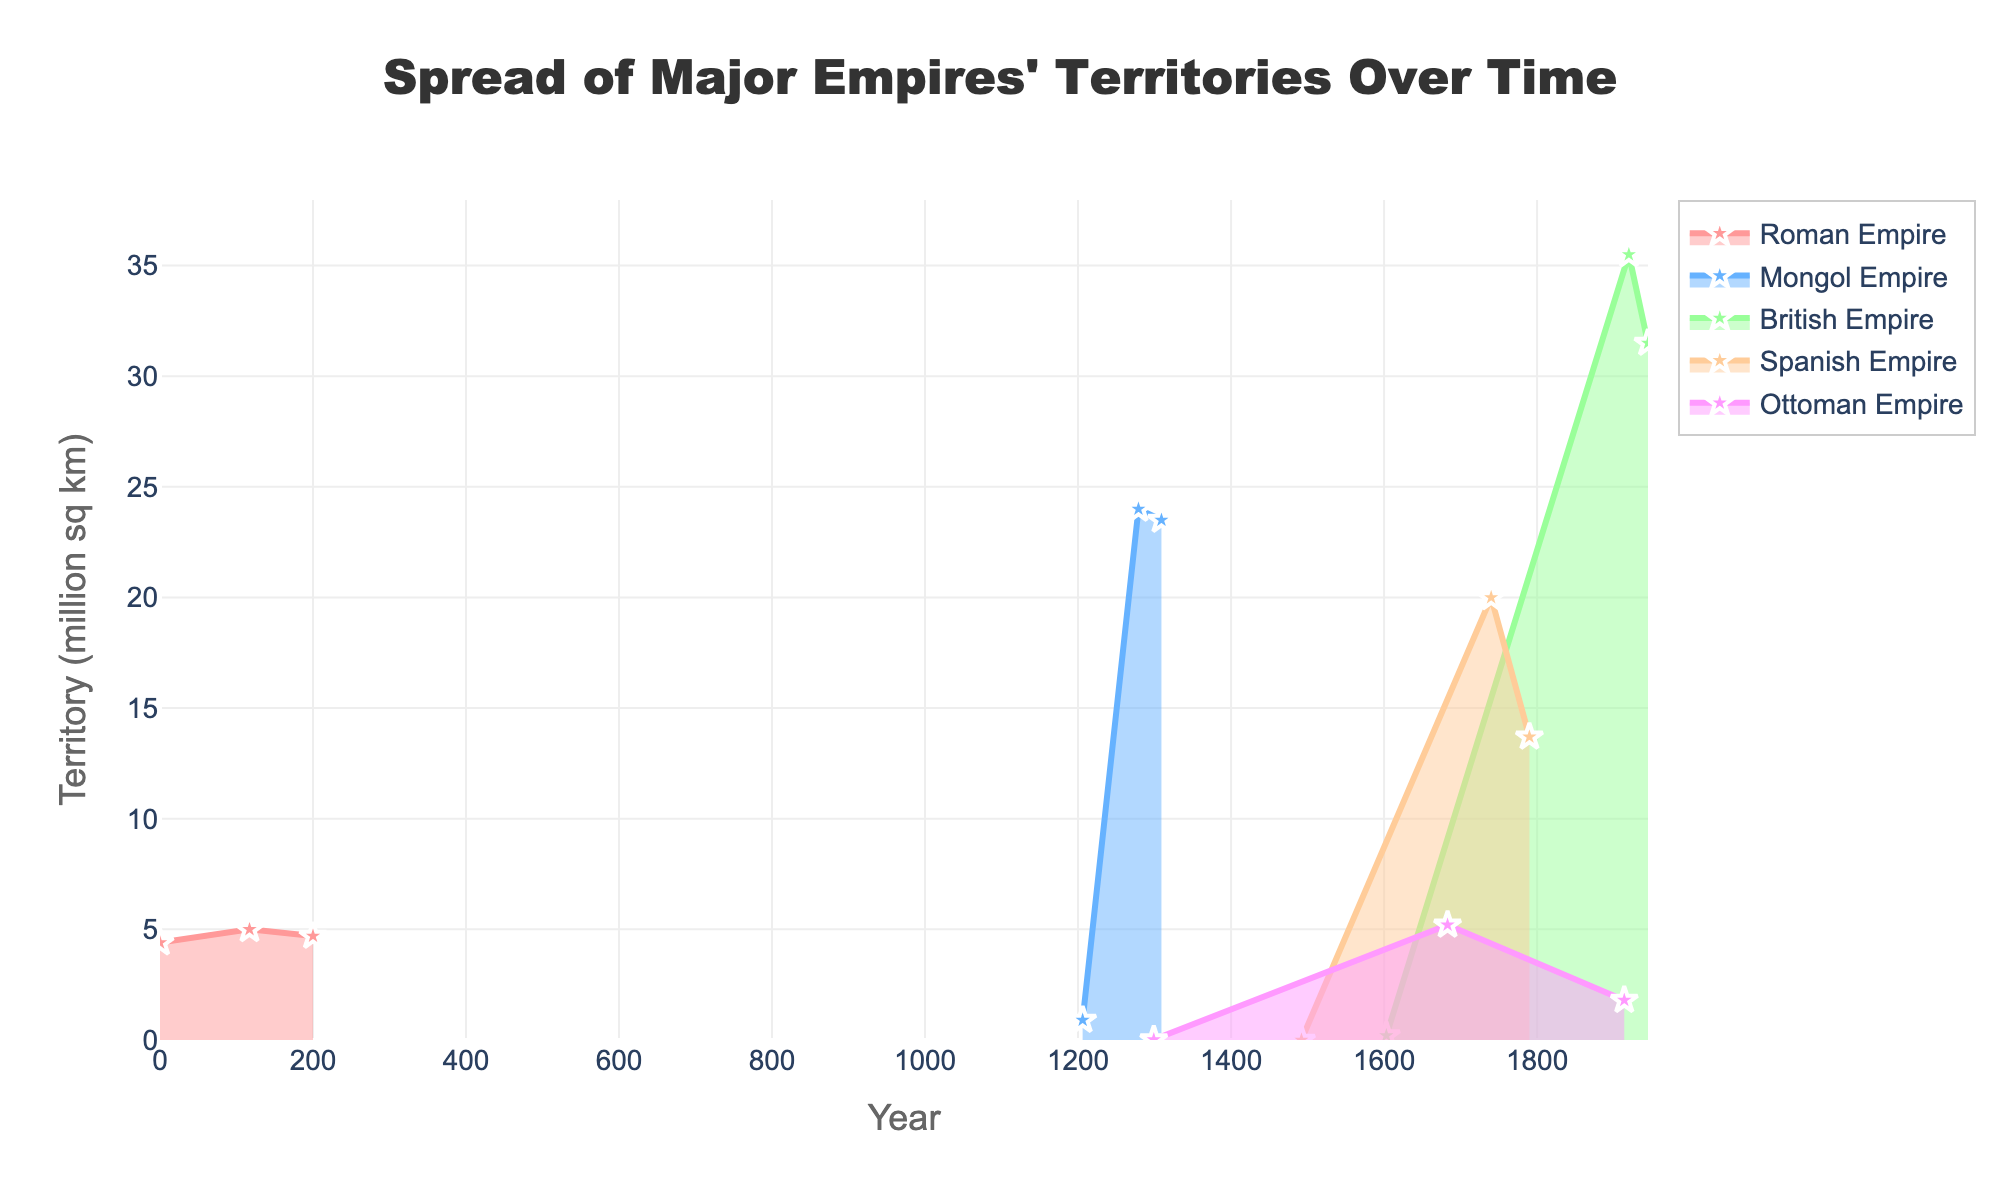What is the title of this figure? The title is written at the top center of the chart, in a large font size. It reads "Spread of Major Empires' Territories Over Time".
Answer: Spread of Major Empires' Territories Over Time Which empire had the largest territory at its peak according to the chart? The British Empire had the largest territory, reaching its peak at about 35.5 million sq km around the year 1920.
Answer: British Empire How did the territory of the Roman Empire change between 0 and 200 AD? From the plot, we see that the Roman Empire's territory grew from 4.4 million sq km in year 0 to 5 million sq km by year 117 AD, and then slightly decreased to 4.7 million sq km by the year 200 AD. This shows an initial increase followed by a slight decrease.
Answer: Increased, then decreased Which empire expanded the fastest during the covered time periods? The Mongol Empire shows the most rapid expansion, growing from 0.9 million sq km in 1206 to 24 million sq km by 1279.
Answer: Mongol Empire Compare the size of the Ottoman Empire in 1683 and 1914. Which was larger and by how much? The Ottoman Empire was larger in 1683, with 5.2 million sq km compared to 1.8 million sq km in 1914. The difference is 5.2 - 1.8 = 3.4 million sq km.
Answer: 1683 by 3.4 million sq km Which empire had a territory of less than 1 million sq km at the earliest date shown? Both the Spanish Empire in 1492 (0.002 million sq km) and the Ottoman Empire in 1299 (0.02 million sq km) had territories of less than 1 million sq km at their earliest recorded dates.
Answer: Spanish Empire and Ottoman Empire What was the approximate territory of the Spanish Empire in 1740? The Spanish Empire had a territory approximately 20 million sq km in the year 1740, as indicated by the plot.
Answer: 20 million sq km How did the British Empire's territory change between 1603 and 1945? The British Empire's territory started at 0.2 million sq km in 1603, peaked at 35.5 million sq km in 1920, and then slightly decreased to 31.5 million sq km by 1945, displaying significant growth and a slight decline.
Answer: Increased, then decreased Which empire had the second largest territory around the year 1300? The plot shows that the Mongol Empire had the second largest territory around the year 1300 after its peak of 24 million sq km. The Roman Empire and the Ottoman Empire had much smaller territories during this period.
Answer: Mongol Empire What is the common trend observed in the territories of all empires over time? Most empires show a trend where the territory initially increases to a peak before later decreasing. This pattern can be observed in the Roman, Mongol, British, Spanish, and Ottoman empires.
Answer: Initial increase, then decrease 